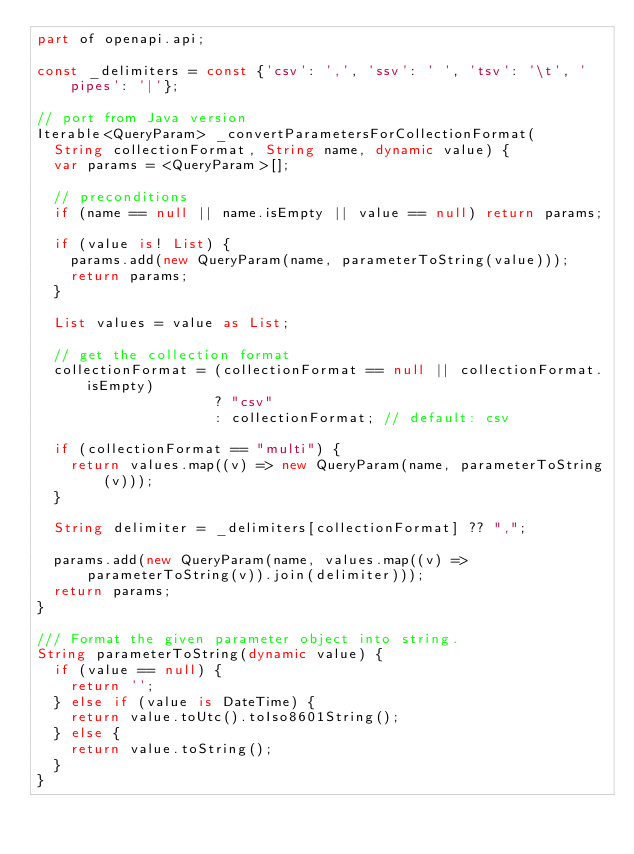Convert code to text. <code><loc_0><loc_0><loc_500><loc_500><_Dart_>part of openapi.api;

const _delimiters = const {'csv': ',', 'ssv': ' ', 'tsv': '\t', 'pipes': '|'};

// port from Java version
Iterable<QueryParam> _convertParametersForCollectionFormat(
  String collectionFormat, String name, dynamic value) {
  var params = <QueryParam>[];

  // preconditions
  if (name == null || name.isEmpty || value == null) return params;

  if (value is! List) {
    params.add(new QueryParam(name, parameterToString(value)));
    return params;
  }

  List values = value as List;

  // get the collection format
  collectionFormat = (collectionFormat == null || collectionFormat.isEmpty)
                     ? "csv"
                     : collectionFormat; // default: csv

  if (collectionFormat == "multi") {
    return values.map((v) => new QueryParam(name, parameterToString(v)));
  }

  String delimiter = _delimiters[collectionFormat] ?? ",";

  params.add(new QueryParam(name, values.map((v) => parameterToString(v)).join(delimiter)));
  return params;
}

/// Format the given parameter object into string.
String parameterToString(dynamic value) {
  if (value == null) {
    return '';
  } else if (value is DateTime) {
    return value.toUtc().toIso8601String();
  } else {
    return value.toString();
  }
}
</code> 